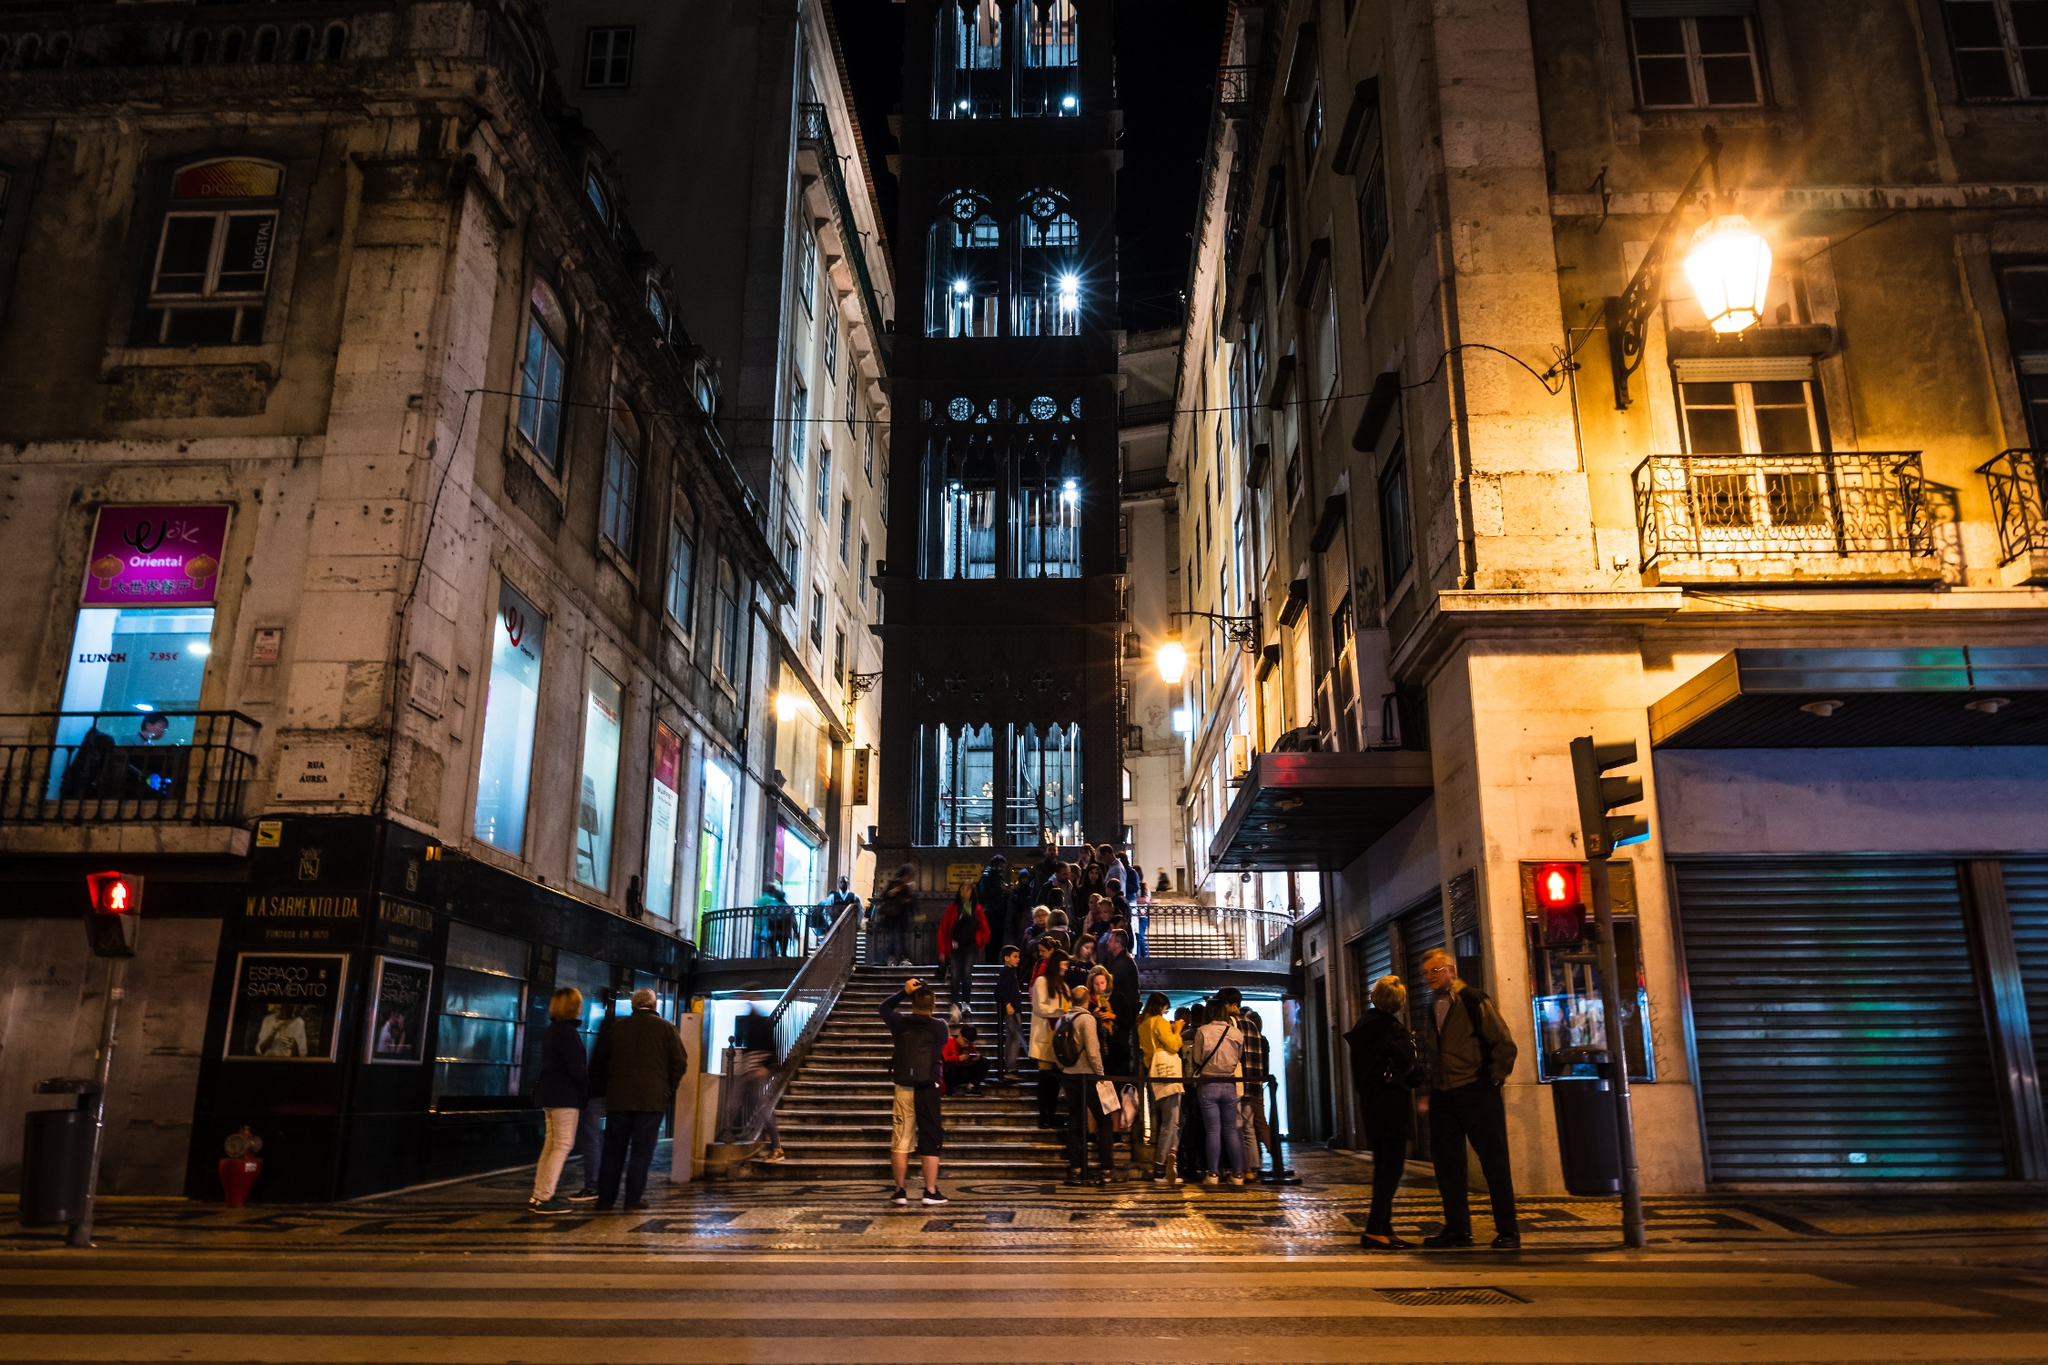Can you describe the architectural style of the Elevator. The architectural style of the Santa Justa Lift is predominantly Gothic Revival. Its intricate designs, pointed arches, and detailed metalwork are characteristic of this style, which was popular in the late 19th and early 20th centuries. The elevator's iron structure includes ornate patterns and decorations that highlight the craftsmanship of the time. The overall design is both functional and aesthetically pleasing, showcasing the blend of industrial innovation and historical architectural style. 